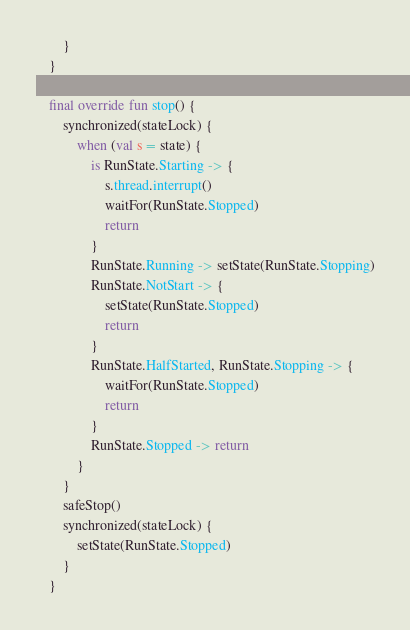<code> <loc_0><loc_0><loc_500><loc_500><_Kotlin_>        }
    }

    final override fun stop() {
        synchronized(stateLock) {
            when (val s = state) {
                is RunState.Starting -> {
                    s.thread.interrupt()
                    waitFor(RunState.Stopped)
                    return
                }
                RunState.Running -> setState(RunState.Stopping)
                RunState.NotStart -> {
                    setState(RunState.Stopped)
                    return
                }
                RunState.HalfStarted, RunState.Stopping -> {
                    waitFor(RunState.Stopped)
                    return
                }
                RunState.Stopped -> return
            }
        }
        safeStop()
        synchronized(stateLock) {
            setState(RunState.Stopped)
        }
    }
</code> 